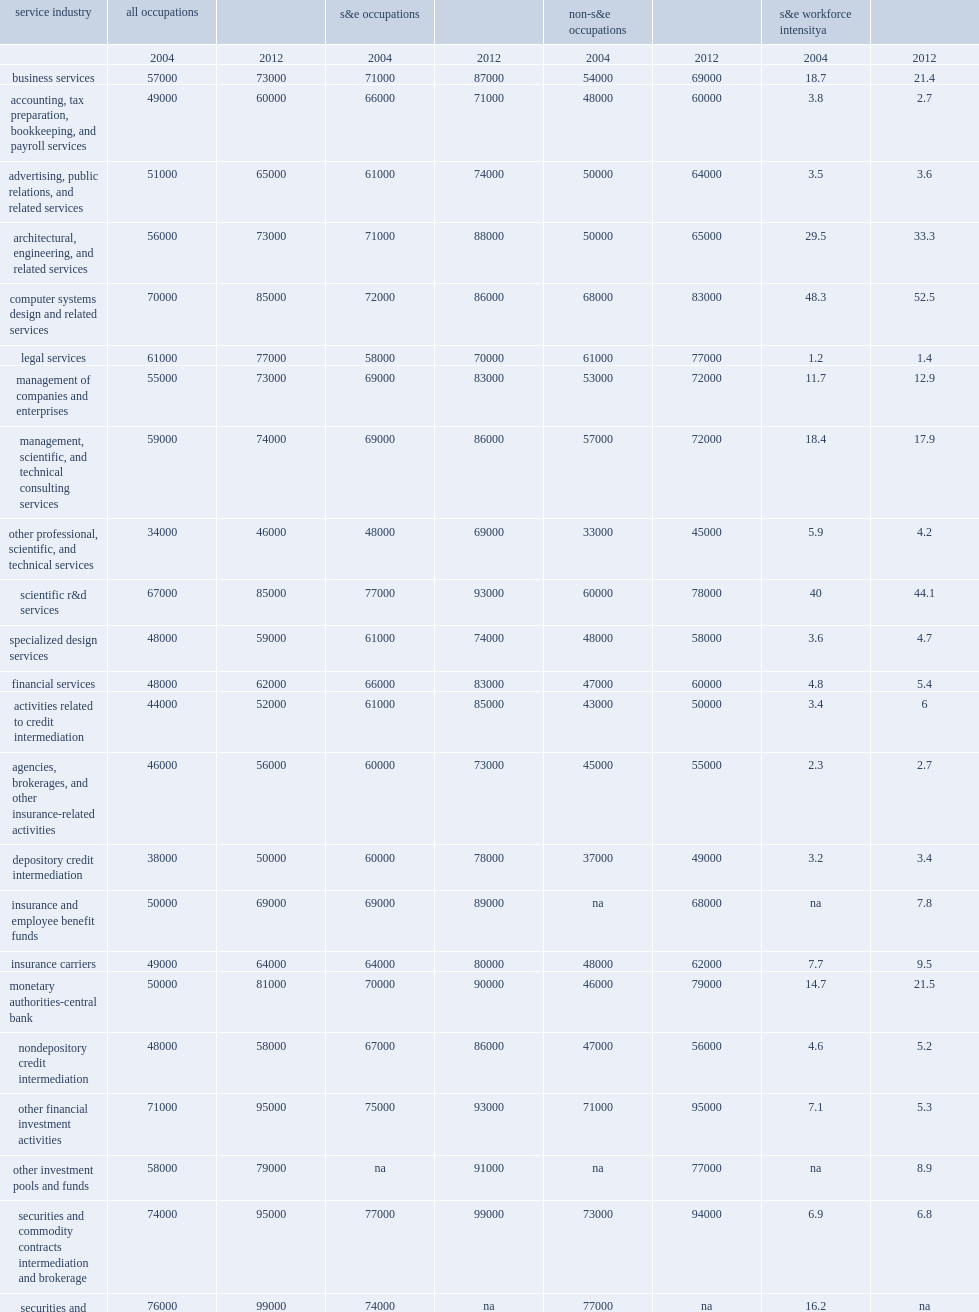Within business services, how many percent was s&e workforce intensity in computer systems design? 52.5. Within business services, how many percent was s&e workforce intensity in scientific r&d? 44.1. Within business services, how many percent was s&e workforce intensity in architectural and engineering? 33.3. How many percent of information services which has the next highest s&e intensity? 16.6. How many percent of software publishers which have the highest s&e intensities within this industry sector? 45.9. How many percent of data processing, hosting, and related services which have the highest s&e intensities within this industry sector? 38.0. 